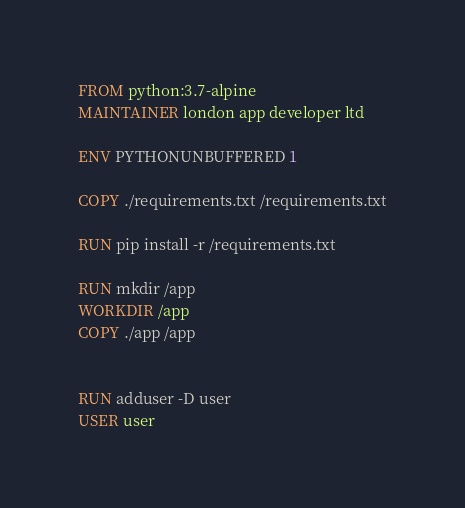<code> <loc_0><loc_0><loc_500><loc_500><_Dockerfile_>FROM python:3.7-alpine
MAINTAINER london app developer ltd

ENV PYTHONUNBUFFERED 1

COPY ./requirements.txt /requirements.txt

RUN pip install -r /requirements.txt

RUN mkdir /app
WORKDIR /app
COPY ./app /app


RUN adduser -D user
USER user</code> 